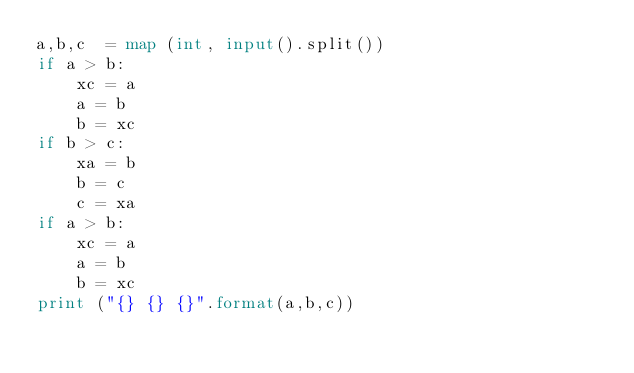Convert code to text. <code><loc_0><loc_0><loc_500><loc_500><_Python_>a,b,c  = map (int, input().split())
if a > b:
    xc = a
    a = b
    b = xc
if b > c:
    xa = b
    b = c
    c = xa
if a > b:
    xc = a
    a = b
    b = xc
print ("{} {} {}".format(a,b,c))

</code> 